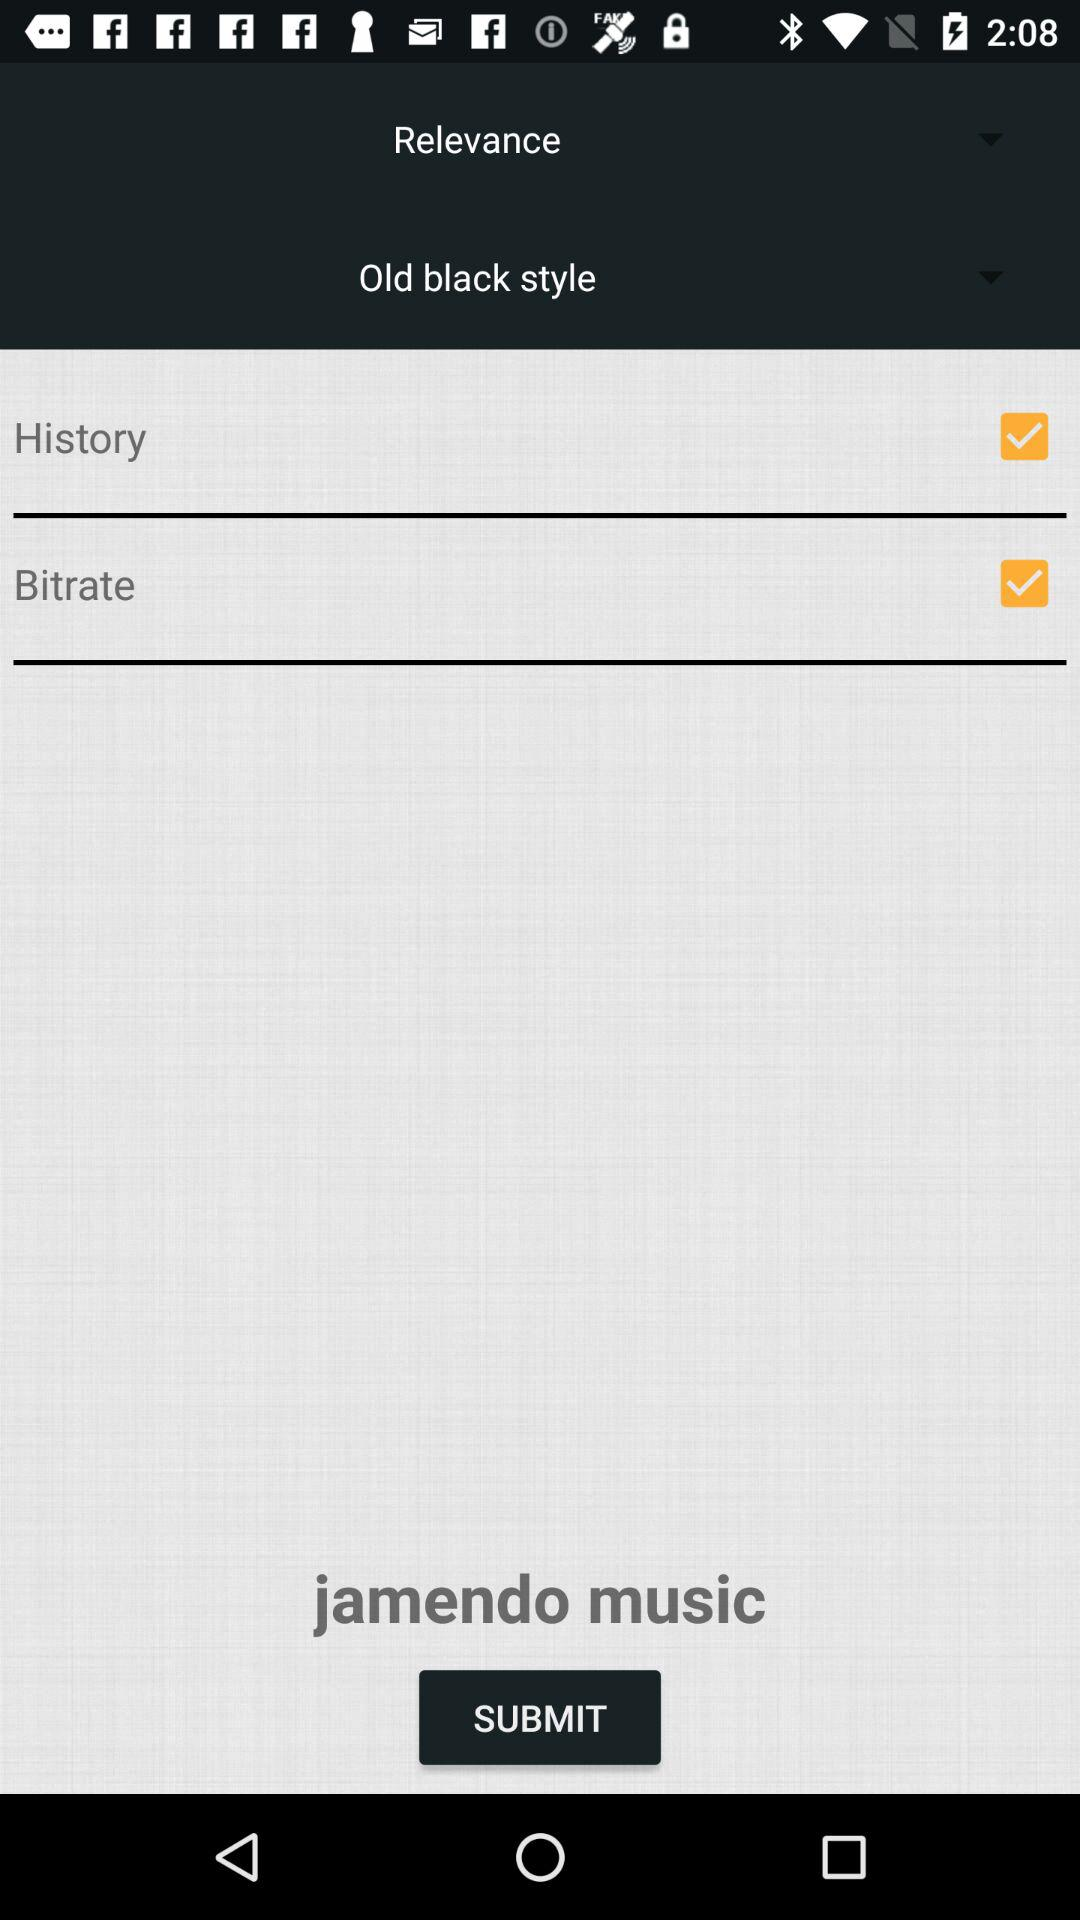How far back does the history go?
When the provided information is insufficient, respond with <no answer>. <no answer> 